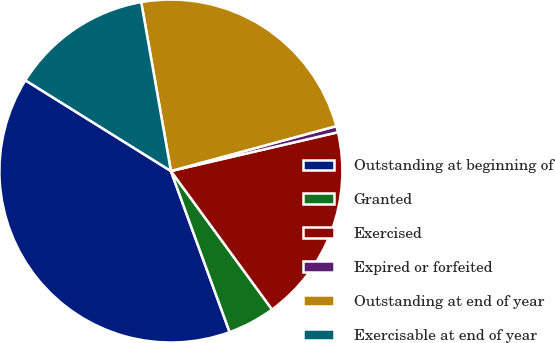Convert chart. <chart><loc_0><loc_0><loc_500><loc_500><pie_chart><fcel>Outstanding at beginning of<fcel>Granted<fcel>Exercised<fcel>Expired or forfeited<fcel>Outstanding at end of year<fcel>Exercisable at end of year<nl><fcel>39.44%<fcel>4.48%<fcel>18.59%<fcel>0.59%<fcel>23.55%<fcel>13.36%<nl></chart> 